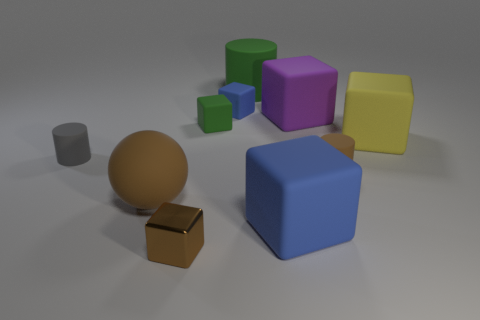What number of large rubber things are both right of the shiny cube and in front of the large yellow rubber cube?
Offer a terse response. 1. What is the shape of the yellow matte thing?
Your response must be concise. Cube. What number of other things are the same material as the small green thing?
Provide a short and direct response. 8. There is a cylinder in front of the small cylinder on the left side of the small thing that is behind the tiny green matte block; what color is it?
Give a very brief answer. Brown. There is a cylinder that is the same size as the brown matte ball; what material is it?
Give a very brief answer. Rubber. What number of objects are either small things on the right side of the brown sphere or brown rubber things?
Offer a terse response. 5. Are any big gray spheres visible?
Your response must be concise. No. There is a small block that is in front of the gray cylinder; what is its material?
Offer a terse response. Metal. What is the material of the big ball that is the same color as the small metallic block?
Keep it short and to the point. Rubber. How many big objects are brown cylinders or metal things?
Give a very brief answer. 0. 